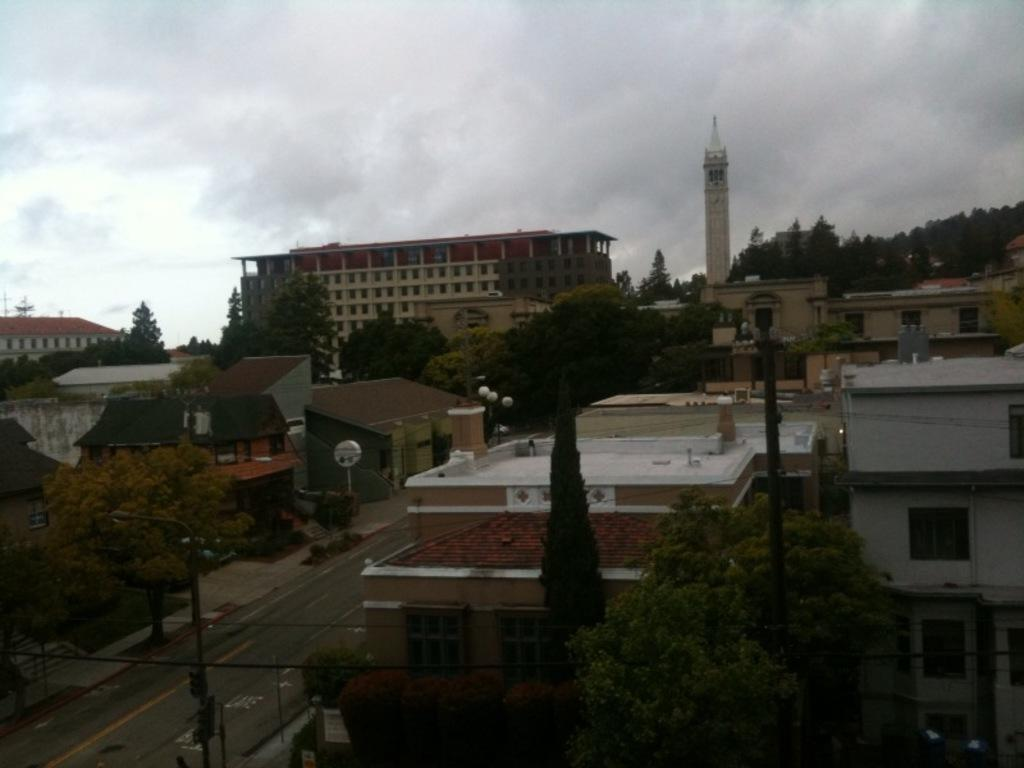What type of pathway is visible in the image? There is a road in the picture. What natural elements can be seen in the image? There are trees in the picture. What man-made structures are present in the image? There are buildings in the picture. What vertical structures can be seen in the image? There are poles in the picture. What is the condition of the sky in the image? The sky is clear in the picture. How does the crowd affect the distribution of traffic on the road in the image? There is no crowd present in the image, so it is not possible to determine how it would affect the distribution of traffic. What type of horn is visible on the poles in the image? There are no horns visible on the poles in the image. 